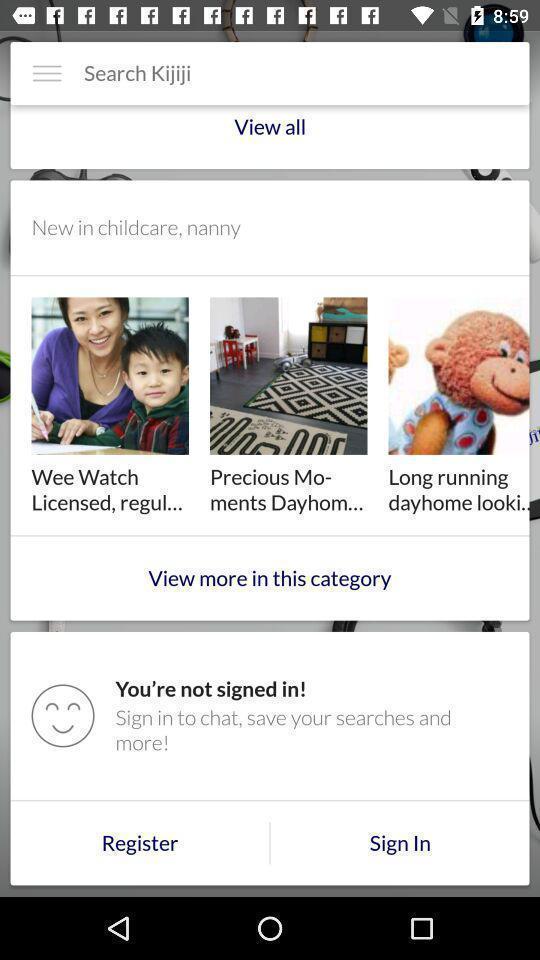Summarize the information in this screenshot. Sign in page and other options displayed. 